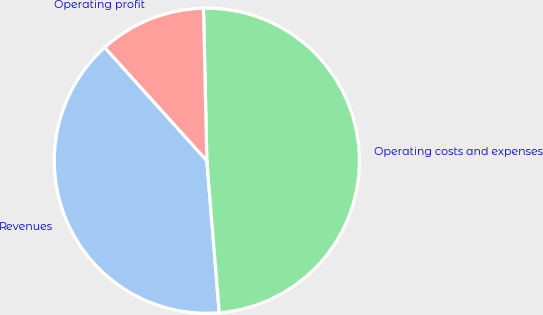Convert chart to OTSL. <chart><loc_0><loc_0><loc_500><loc_500><pie_chart><fcel>Revenues<fcel>Operating costs and expenses<fcel>Operating profit<nl><fcel>39.62%<fcel>49.06%<fcel>11.32%<nl></chart> 